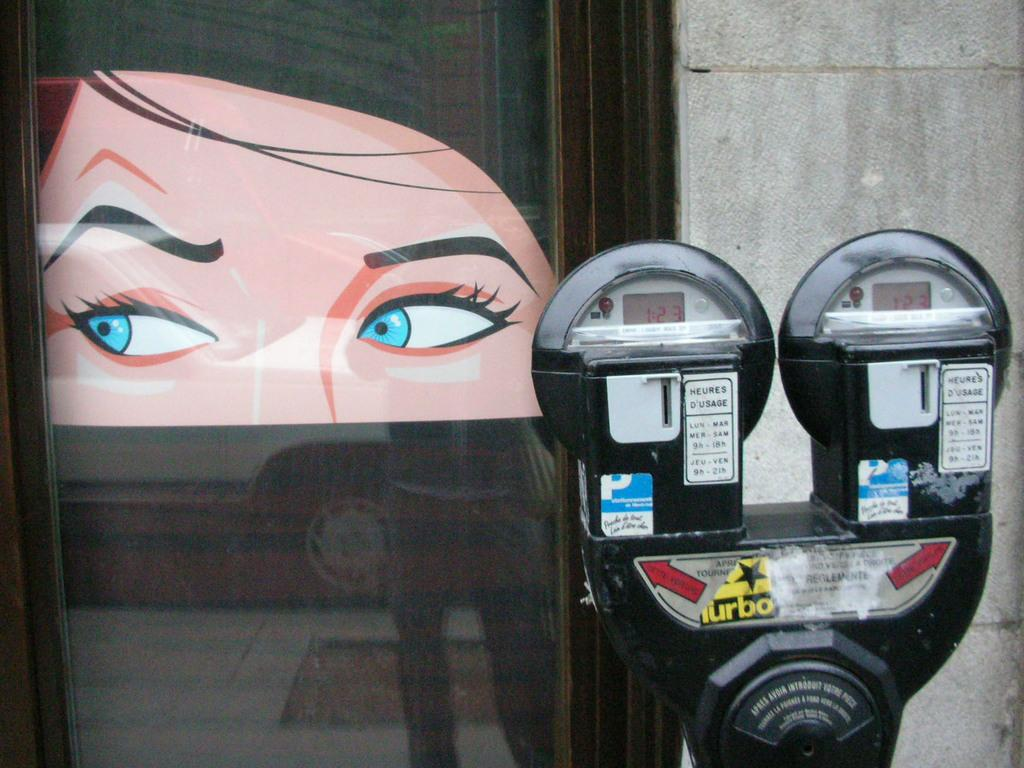Provide a one-sentence caption for the provided image. parking meters with red display showing 1:23 on them and drawing of a womans head in window behind meters. 